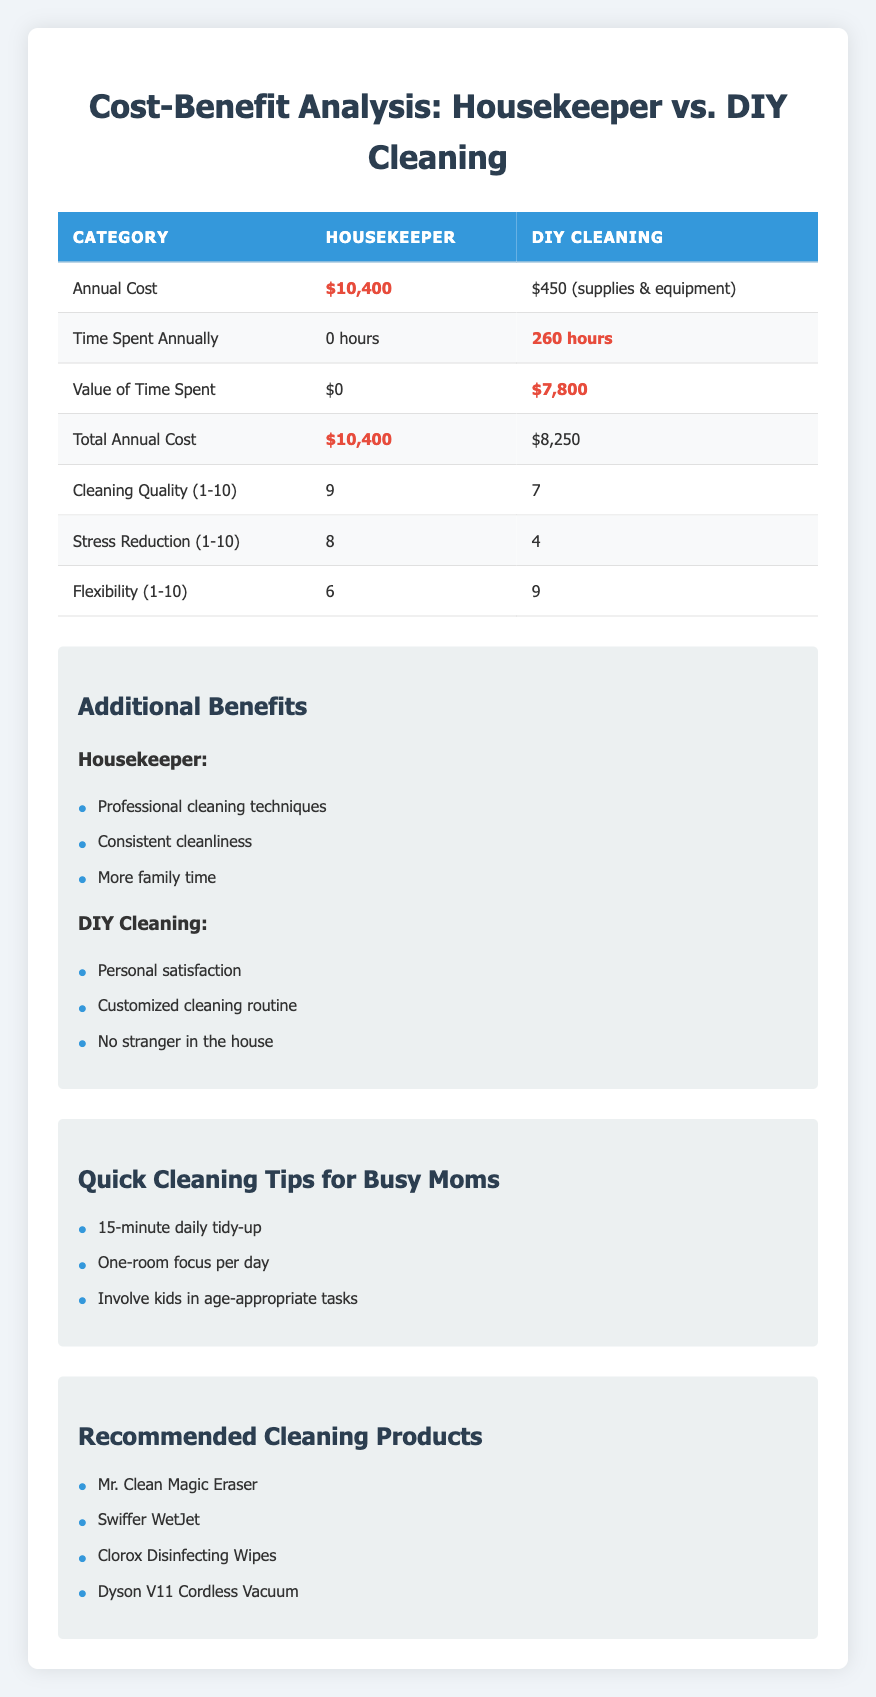What is the annual cost of hiring a housekeeper? The table clearly states the annual cost for a housekeeper is $10,400.
Answer: $10,400 What are the total annual costs associated with DIY cleaning? According to the table, the DIY cleaning costs include $300 for cleaning supplies and $150 for equipment, totaling $450. However, when considering the value of the time spent (260 hours at $30/hour), the total cost becomes $450 + $7,800 = $8,250.
Answer: $8,250 Does hiring a housekeeper provide a higher cleaning quality than DIY cleaning? The cleaning quality rating for a housekeeper is 9, while for DIY cleaning it is 7. Higher numbers indicate better quality, so yes, hiring a housekeeper provides a higher quality.
Answer: Yes What is the difference in time savings between hiring a housekeeper and doing DIY cleaning? The time saved when hiring a housekeeper is 260 hours, while DIY cleaning results in 0 hours saved. Therefore, the difference is 260 - 0 = 260 hours.
Answer: 260 hours Is the flexibility of DIY cleaning higher than that of hiring a housekeeper? The table shows that flexibility for DIY cleaning is rated 9, whereas for hiring a housekeeper it is rated 6. Since 9 is higher than 6, DIY cleaning offers greater flexibility.
Answer: Yes What is the total value of time spent on DIY cleaning annually? The table indicates that during DIY cleaning, 260 hours are spent weekly, valued at $30/hour. Therefore, the total value is 260 hours * $30 = $7,800.
Answer: $7,800 Which option provides better stress reduction, and what are the respective scores? The stress reduction for hiring a housekeeper is scored at 8, while DIY cleaning is scored at 4. Since 8 is greater than 4, hiring a housekeeper provides better stress reduction.
Answer: Housekeeper (8), DIY Cleaning (4) How much more does hiring a housekeeper cost compared to DIY cleaning when considering all factors? The annual cost for a housekeeper is $10,400, while the total cost of DIY cleaning is $8,250. The difference is $10,400 - $8,250 = $2,150.
Answer: $2,150 Which additional benefits are exclusive to hiring a housekeeper? The table lists benefits for hiring a housekeeper as professional cleaning techniques, consistent cleanliness, and more family time. These are not listed as benefits for DIY cleaning.
Answer: Professional techniques, consistent cleanliness, more family time 